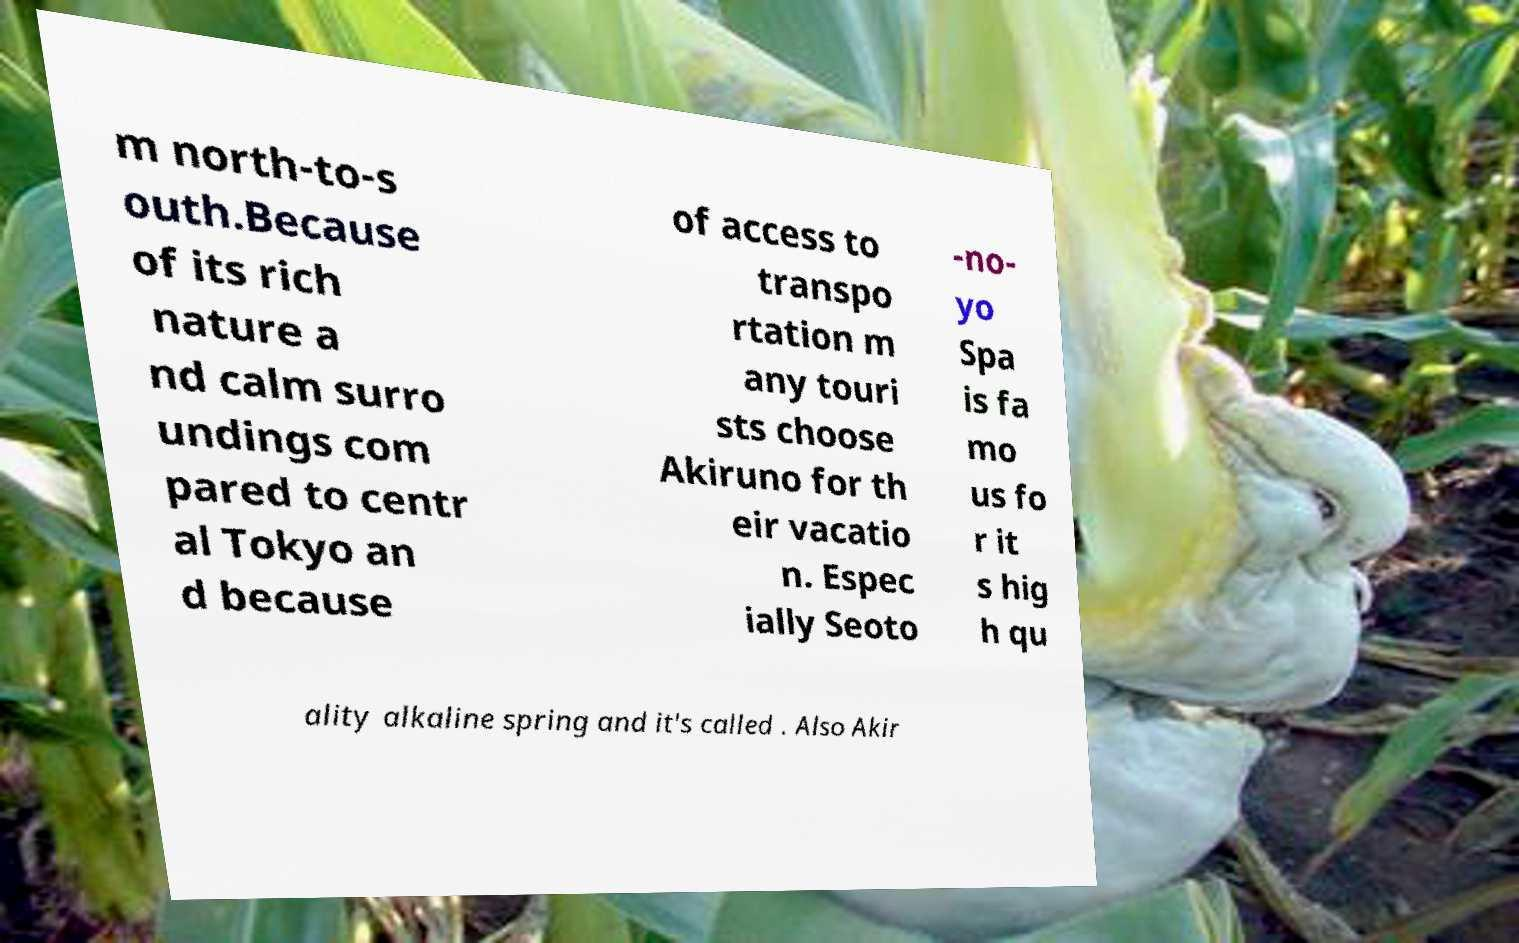Can you accurately transcribe the text from the provided image for me? m north-to-s outh.Because of its rich nature a nd calm surro undings com pared to centr al Tokyo an d because of access to transpo rtation m any touri sts choose Akiruno for th eir vacatio n. Espec ially Seoto -no- yo Spa is fa mo us fo r it s hig h qu ality alkaline spring and it's called . Also Akir 